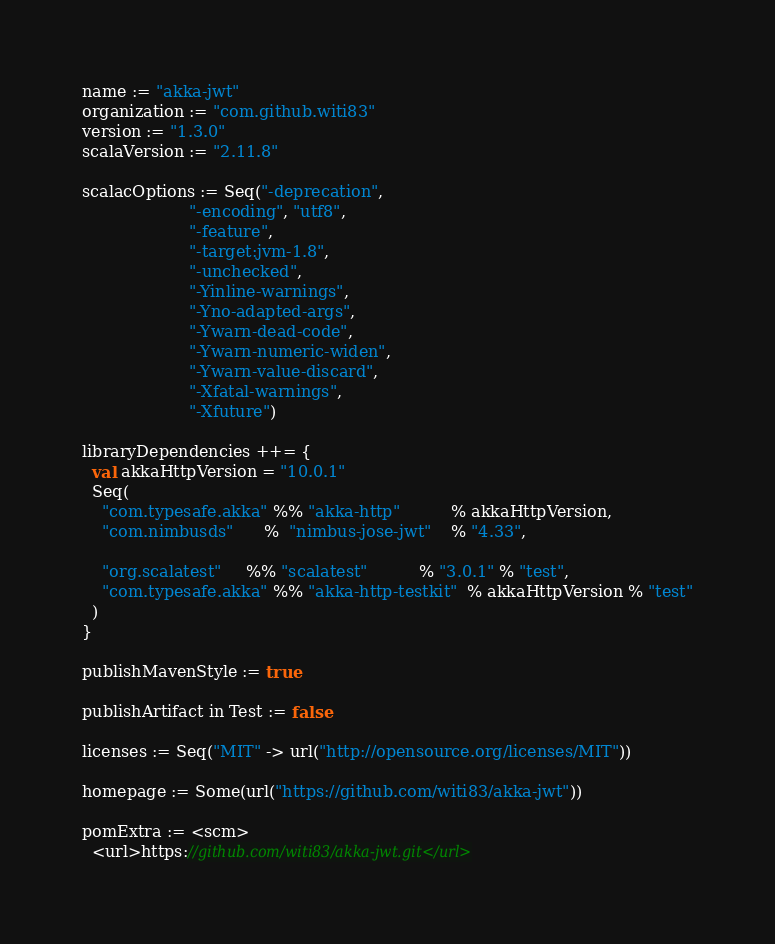<code> <loc_0><loc_0><loc_500><loc_500><_Scala_>name := "akka-jwt"
organization := "com.github.witi83"
version := "1.3.0"
scalaVersion := "2.11.8"

scalacOptions := Seq("-deprecation",
                     "-encoding", "utf8",
                     "-feature",
                     "-target:jvm-1.8",
                     "-unchecked",
                     "-Yinline-warnings",
                     "-Yno-adapted-args",
                     "-Ywarn-dead-code",
                     "-Ywarn-numeric-widen",
                     "-Ywarn-value-discard",
                     "-Xfatal-warnings",
                     "-Xfuture")

libraryDependencies ++= {
  val akkaHttpVersion = "10.0.1"
  Seq(
    "com.typesafe.akka" %% "akka-http"          % akkaHttpVersion,
    "com.nimbusds"      %  "nimbus-jose-jwt"    % "4.33",

    "org.scalatest"     %% "scalatest"          % "3.0.1" % "test",
    "com.typesafe.akka" %% "akka-http-testkit"  % akkaHttpVersion % "test"
  )
}

publishMavenStyle := true

publishArtifact in Test := false

licenses := Seq("MIT" -> url("http://opensource.org/licenses/MIT"))

homepage := Some(url("https://github.com/witi83/akka-jwt"))

pomExtra := <scm>
  <url>https://github.com/witi83/akka-jwt.git</url></code> 